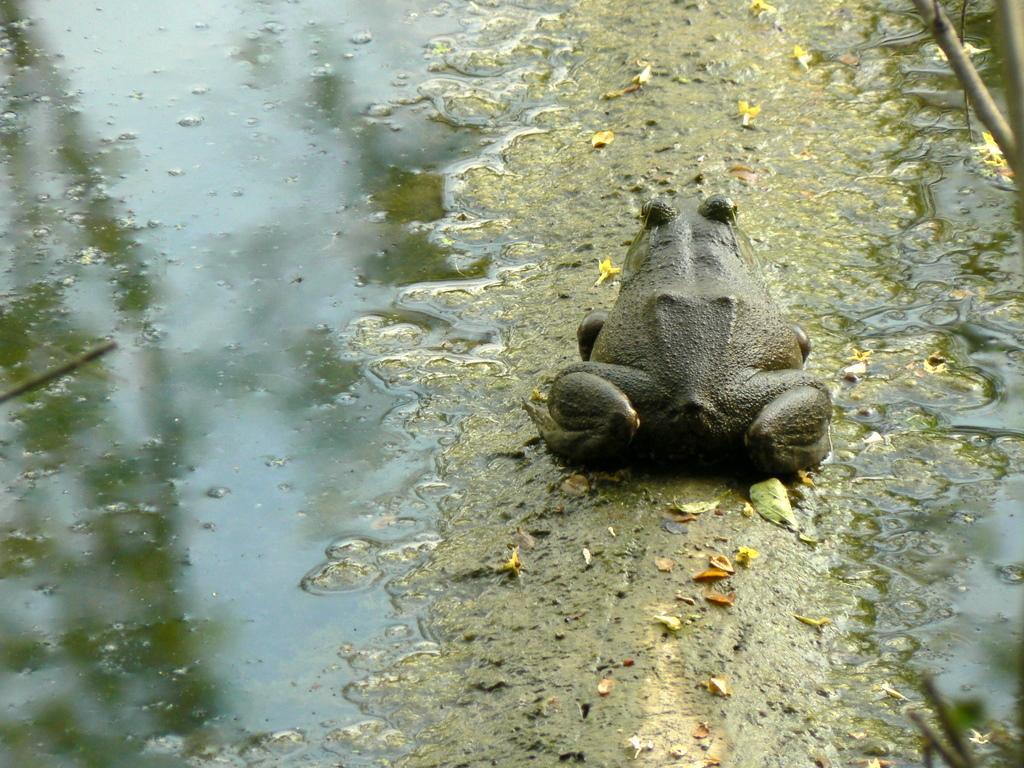Can you describe this image briefly? In this image, we can see a frog beside mud water. 